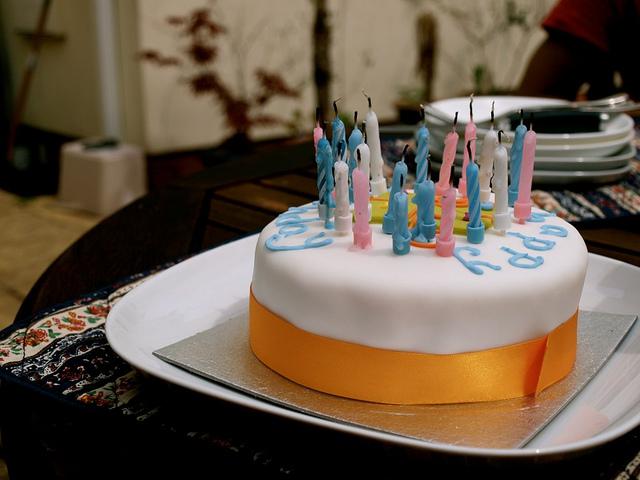How many candles are on the cake?
Short answer required. 19. What is wrapped around the cake?
Concise answer only. Ribbon. How many cake toppers are on the table?
Quick response, please. 1. What type of cake is this?
Answer briefly. Birthday. Is more than one person going to eat this cake?
Quick response, please. Yes. What kind of cake is that?
Quick response, please. Birthday. What shape are the decorative details on the base?
Be succinct. Square. What is the name of this dessert?
Answer briefly. Cake. What color is the ribbon?
Short answer required. Gold. Is the candle burning?
Quick response, please. No. Are there any decorations on the cake?
Be succinct. Yes. What color is the writing on the cake?
Keep it brief. Blue. Does the cake have stiff peaks?
Be succinct. No. How many candles aren't lit?
Answer briefly. 19. What is the name on the side of the cake?
Be succinct. None. For what occasion would you have a cake like this one?
Keep it brief. Birthday. 